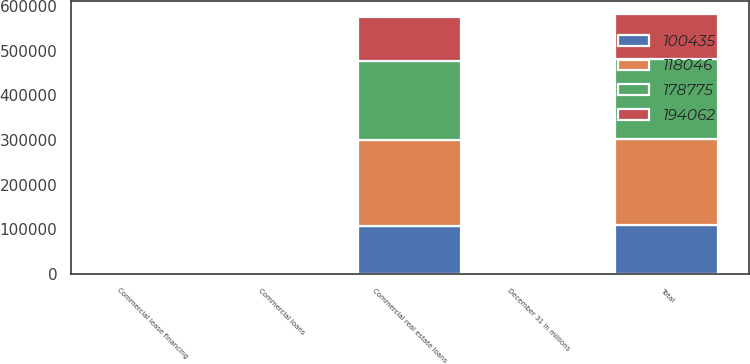Convert chart. <chart><loc_0><loc_0><loc_500><loc_500><stacked_bar_chart><ecel><fcel>December 31 in millions<fcel>Commercial real estate loans<fcel>Commercial lease financing<fcel>Commercial loans<fcel>Total<nl><fcel>118046<fcel>2014<fcel>191407<fcel>722<fcel>344<fcel>194062<nl><fcel>178775<fcel>2013<fcel>177731<fcel>717<fcel>327<fcel>178775<nl><fcel>100435<fcel>2012<fcel>107630<fcel>520<fcel>343<fcel>108493<nl><fcel>194062<fcel>2011<fcel>99608<fcel>521<fcel>306<fcel>100435<nl></chart> 